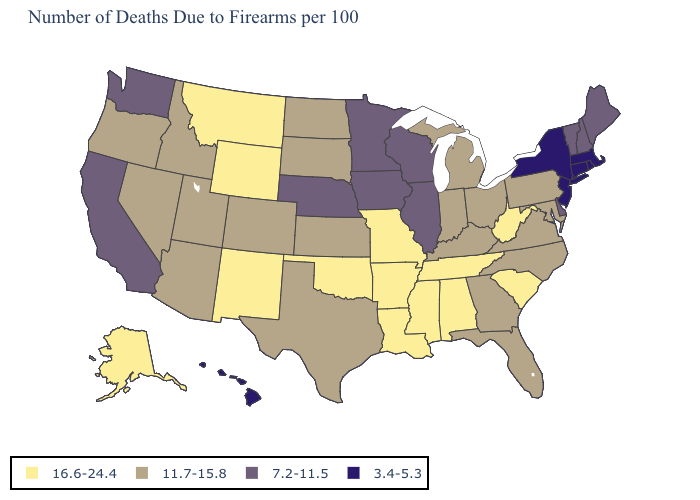Name the states that have a value in the range 11.7-15.8?
Write a very short answer. Arizona, Colorado, Florida, Georgia, Idaho, Indiana, Kansas, Kentucky, Maryland, Michigan, Nevada, North Carolina, North Dakota, Ohio, Oregon, Pennsylvania, South Dakota, Texas, Utah, Virginia. Name the states that have a value in the range 11.7-15.8?
Answer briefly. Arizona, Colorado, Florida, Georgia, Idaho, Indiana, Kansas, Kentucky, Maryland, Michigan, Nevada, North Carolina, North Dakota, Ohio, Oregon, Pennsylvania, South Dakota, Texas, Utah, Virginia. What is the value of Idaho?
Be succinct. 11.7-15.8. What is the value of Kentucky?
Give a very brief answer. 11.7-15.8. Does Michigan have the lowest value in the MidWest?
Write a very short answer. No. Does Wyoming have the highest value in the West?
Be succinct. Yes. Does the first symbol in the legend represent the smallest category?
Answer briefly. No. What is the highest value in the Northeast ?
Write a very short answer. 11.7-15.8. How many symbols are there in the legend?
Answer briefly. 4. Among the states that border Arizona , which have the highest value?
Give a very brief answer. New Mexico. Among the states that border Ohio , does West Virginia have the lowest value?
Give a very brief answer. No. Name the states that have a value in the range 7.2-11.5?
Answer briefly. California, Delaware, Illinois, Iowa, Maine, Minnesota, Nebraska, New Hampshire, Vermont, Washington, Wisconsin. Does the first symbol in the legend represent the smallest category?
Concise answer only. No. What is the value of Pennsylvania?
Quick response, please. 11.7-15.8. Name the states that have a value in the range 11.7-15.8?
Give a very brief answer. Arizona, Colorado, Florida, Georgia, Idaho, Indiana, Kansas, Kentucky, Maryland, Michigan, Nevada, North Carolina, North Dakota, Ohio, Oregon, Pennsylvania, South Dakota, Texas, Utah, Virginia. 